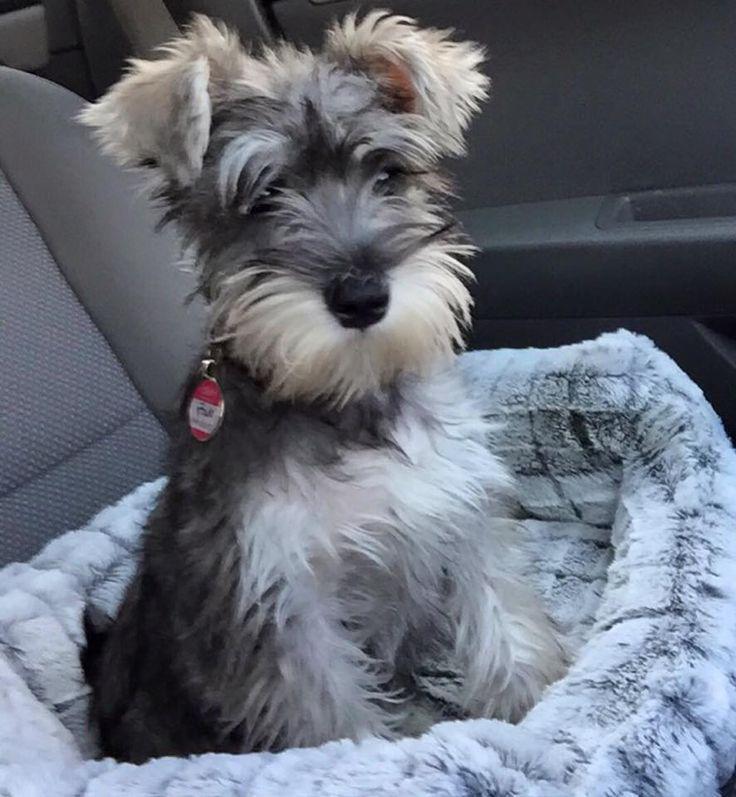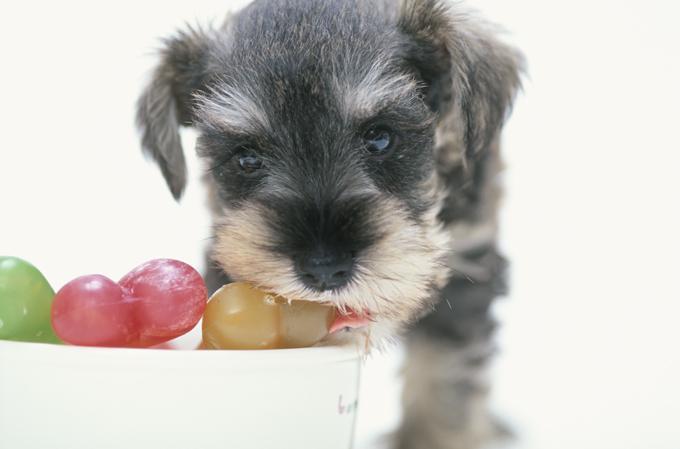The first image is the image on the left, the second image is the image on the right. For the images shown, is this caption "An image shows a dog with its mouth on some type of chew bone." true? Answer yes or no. Yes. The first image is the image on the left, the second image is the image on the right. Evaluate the accuracy of this statement regarding the images: "The animal on the right is lying on a green colored surface.". Is it true? Answer yes or no. No. 